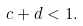Convert formula to latex. <formula><loc_0><loc_0><loc_500><loc_500>c + d < 1 .</formula> 